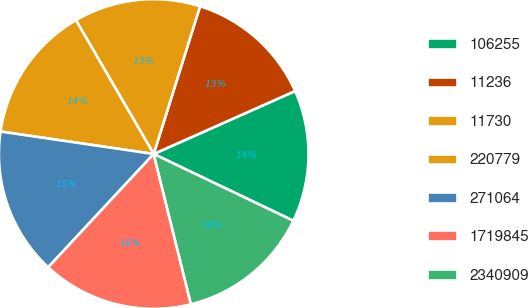Convert chart to OTSL. <chart><loc_0><loc_0><loc_500><loc_500><pie_chart><fcel>106255<fcel>11236<fcel>11730<fcel>220779<fcel>271064<fcel>1719845<fcel>2340909<nl><fcel>13.76%<fcel>13.49%<fcel>13.22%<fcel>14.3%<fcel>15.38%<fcel>15.8%<fcel>14.03%<nl></chart> 